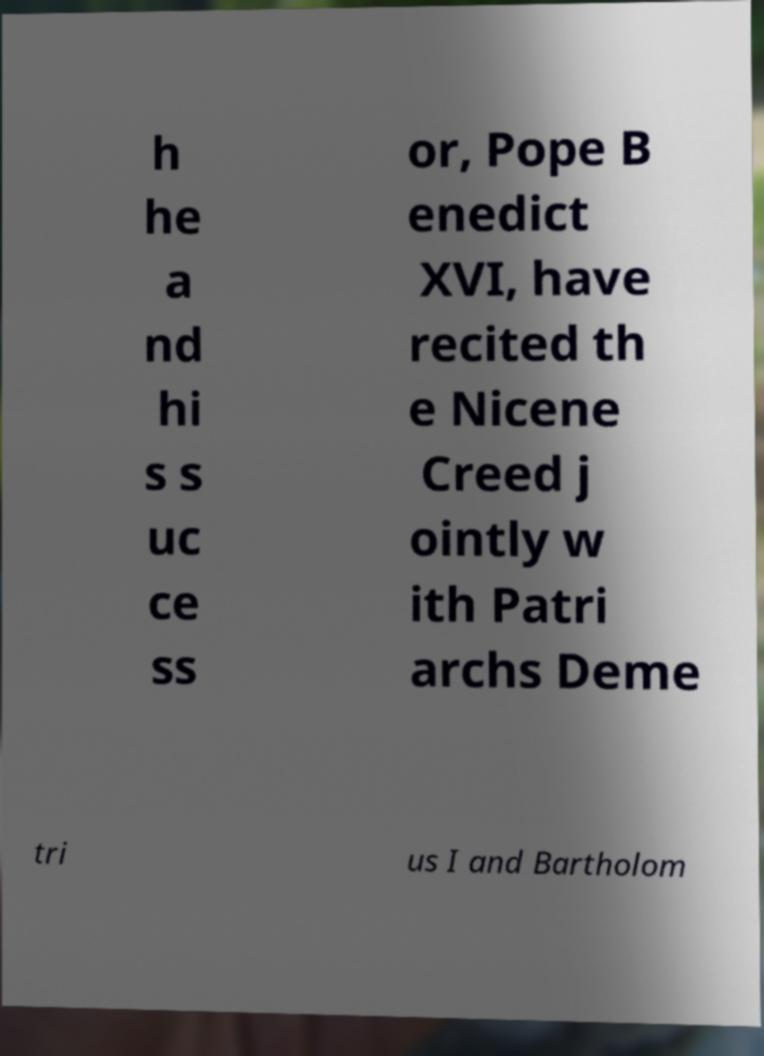Please read and relay the text visible in this image. What does it say? h he a nd hi s s uc ce ss or, Pope B enedict XVI, have recited th e Nicene Creed j ointly w ith Patri archs Deme tri us I and Bartholom 